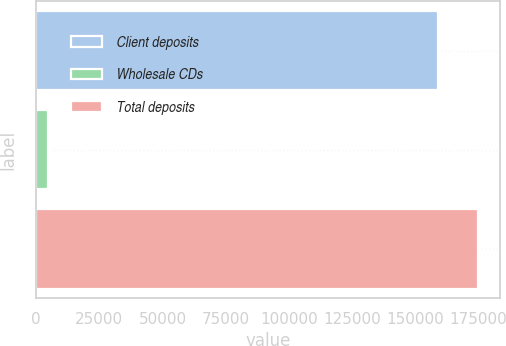Convert chart. <chart><loc_0><loc_0><loc_500><loc_500><bar_chart><fcel>Client deposits<fcel>Wholesale CDs<fcel>Total deposits<nl><fcel>158996<fcel>4812<fcel>174896<nl></chart> 